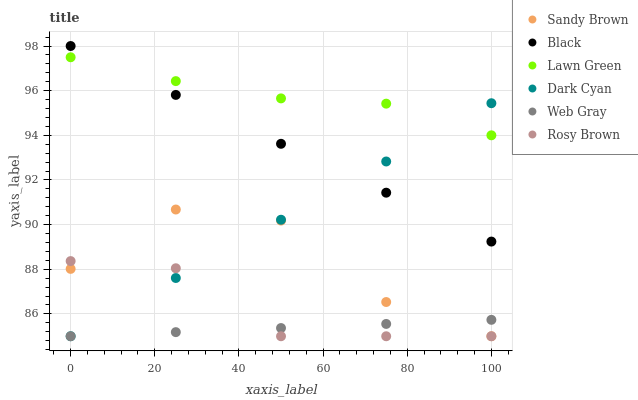Does Web Gray have the minimum area under the curve?
Answer yes or no. Yes. Does Lawn Green have the maximum area under the curve?
Answer yes or no. Yes. Does Rosy Brown have the minimum area under the curve?
Answer yes or no. No. Does Rosy Brown have the maximum area under the curve?
Answer yes or no. No. Is Web Gray the smoothest?
Answer yes or no. Yes. Is Sandy Brown the roughest?
Answer yes or no. Yes. Is Rosy Brown the smoothest?
Answer yes or no. No. Is Rosy Brown the roughest?
Answer yes or no. No. Does Web Gray have the lowest value?
Answer yes or no. Yes. Does Black have the lowest value?
Answer yes or no. No. Does Black have the highest value?
Answer yes or no. Yes. Does Rosy Brown have the highest value?
Answer yes or no. No. Is Sandy Brown less than Black?
Answer yes or no. Yes. Is Lawn Green greater than Web Gray?
Answer yes or no. Yes. Does Rosy Brown intersect Dark Cyan?
Answer yes or no. Yes. Is Rosy Brown less than Dark Cyan?
Answer yes or no. No. Is Rosy Brown greater than Dark Cyan?
Answer yes or no. No. Does Sandy Brown intersect Black?
Answer yes or no. No. 